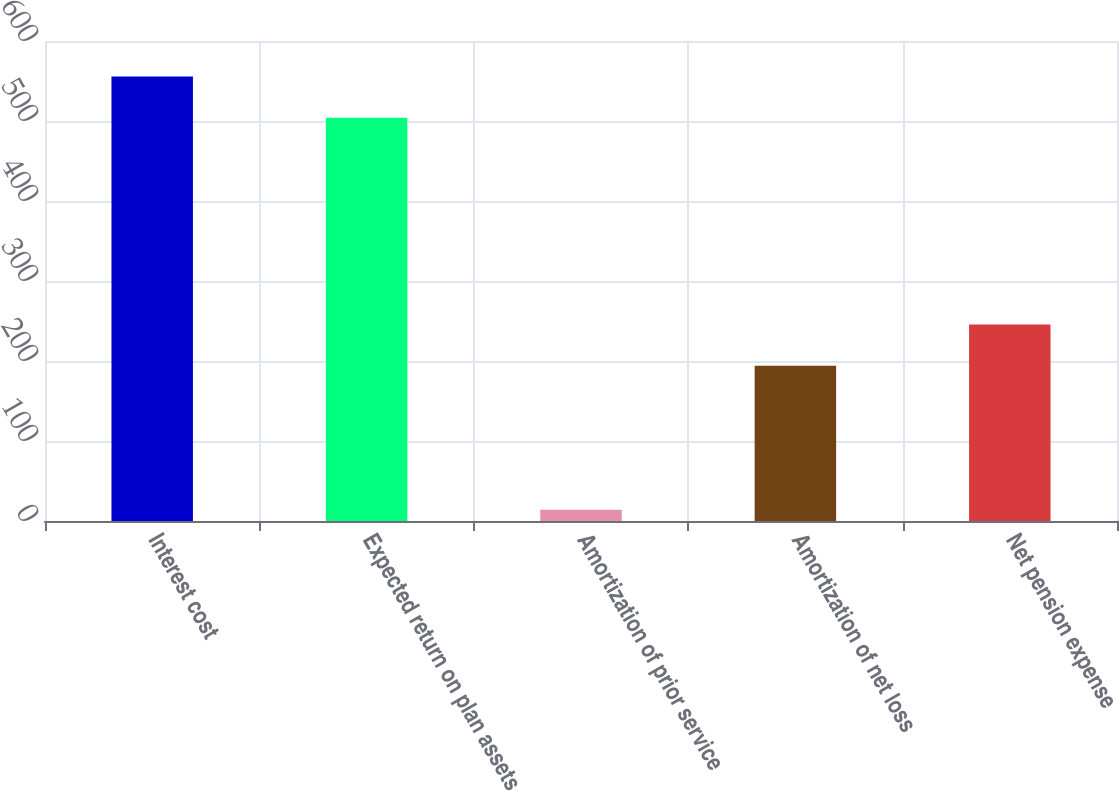<chart> <loc_0><loc_0><loc_500><loc_500><bar_chart><fcel>Interest cost<fcel>Expected return on plan assets<fcel>Amortization of prior service<fcel>Amortization of net loss<fcel>Net pension expense<nl><fcel>555.6<fcel>504<fcel>14<fcel>194<fcel>245.6<nl></chart> 